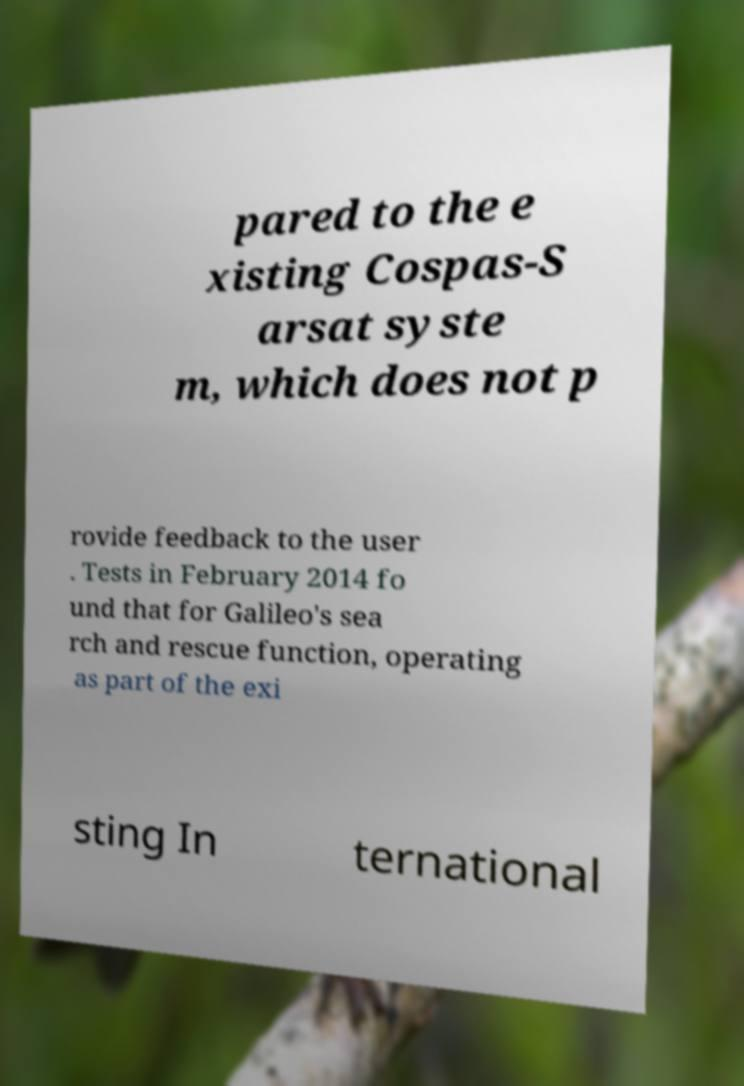Please identify and transcribe the text found in this image. pared to the e xisting Cospas-S arsat syste m, which does not p rovide feedback to the user . Tests in February 2014 fo und that for Galileo's sea rch and rescue function, operating as part of the exi sting In ternational 